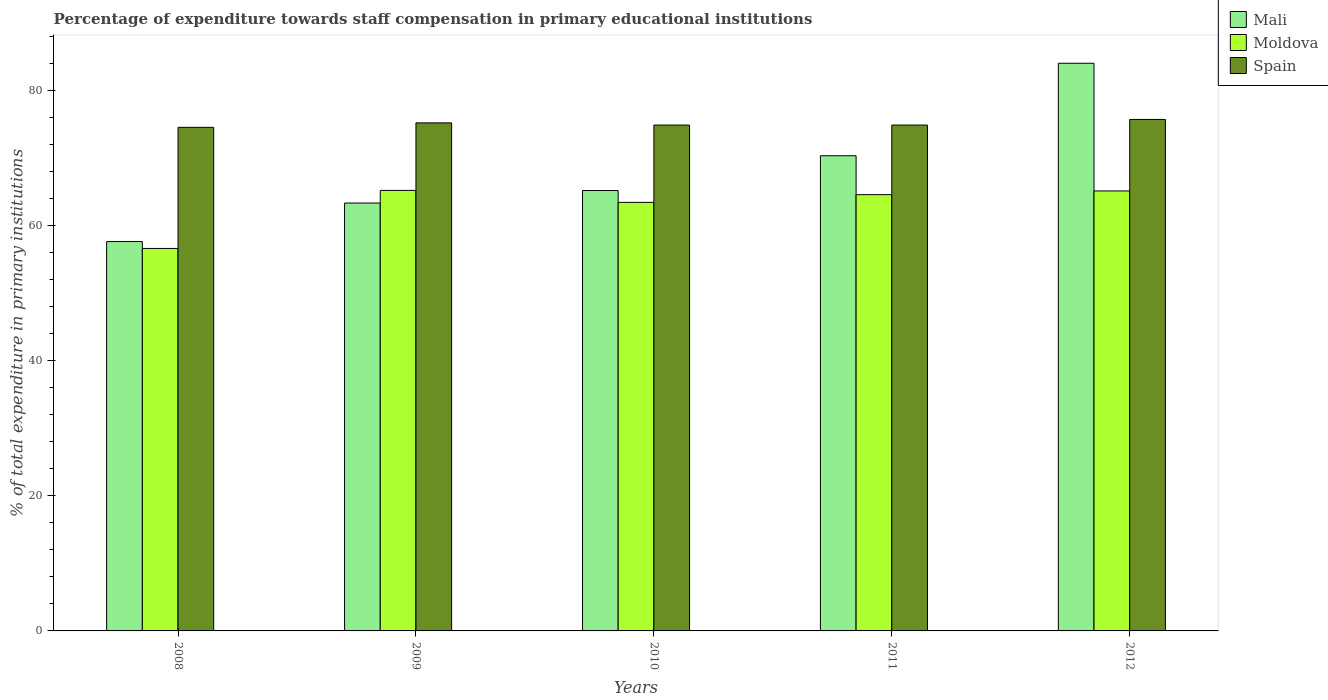How many different coloured bars are there?
Keep it short and to the point. 3. Are the number of bars per tick equal to the number of legend labels?
Provide a short and direct response. Yes. How many bars are there on the 2nd tick from the left?
Offer a very short reply. 3. In how many cases, is the number of bars for a given year not equal to the number of legend labels?
Your answer should be compact. 0. What is the percentage of expenditure towards staff compensation in Mali in 2011?
Your answer should be compact. 70.35. Across all years, what is the maximum percentage of expenditure towards staff compensation in Spain?
Offer a very short reply. 75.72. Across all years, what is the minimum percentage of expenditure towards staff compensation in Spain?
Offer a very short reply. 74.55. In which year was the percentage of expenditure towards staff compensation in Moldova maximum?
Keep it short and to the point. 2009. In which year was the percentage of expenditure towards staff compensation in Spain minimum?
Ensure brevity in your answer.  2008. What is the total percentage of expenditure towards staff compensation in Spain in the graph?
Give a very brief answer. 375.28. What is the difference between the percentage of expenditure towards staff compensation in Spain in 2009 and that in 2011?
Keep it short and to the point. 0.32. What is the difference between the percentage of expenditure towards staff compensation in Spain in 2008 and the percentage of expenditure towards staff compensation in Mali in 2012?
Your answer should be compact. -9.49. What is the average percentage of expenditure towards staff compensation in Mali per year?
Your response must be concise. 68.12. In the year 2009, what is the difference between the percentage of expenditure towards staff compensation in Spain and percentage of expenditure towards staff compensation in Moldova?
Offer a terse response. 10. What is the ratio of the percentage of expenditure towards staff compensation in Spain in 2009 to that in 2011?
Provide a short and direct response. 1. What is the difference between the highest and the second highest percentage of expenditure towards staff compensation in Moldova?
Ensure brevity in your answer.  0.08. What is the difference between the highest and the lowest percentage of expenditure towards staff compensation in Mali?
Keep it short and to the point. 26.39. In how many years, is the percentage of expenditure towards staff compensation in Spain greater than the average percentage of expenditure towards staff compensation in Spain taken over all years?
Keep it short and to the point. 2. What does the 3rd bar from the right in 2008 represents?
Make the answer very short. Mali. How many bars are there?
Provide a short and direct response. 15. Does the graph contain any zero values?
Ensure brevity in your answer.  No. Where does the legend appear in the graph?
Give a very brief answer. Top right. How are the legend labels stacked?
Your answer should be very brief. Vertical. What is the title of the graph?
Offer a very short reply. Percentage of expenditure towards staff compensation in primary educational institutions. Does "Cote d'Ivoire" appear as one of the legend labels in the graph?
Ensure brevity in your answer.  No. What is the label or title of the X-axis?
Make the answer very short. Years. What is the label or title of the Y-axis?
Your answer should be very brief. % of total expenditure in primary institutions. What is the % of total expenditure in primary institutions of Mali in 2008?
Offer a terse response. 57.65. What is the % of total expenditure in primary institutions of Moldova in 2008?
Your answer should be very brief. 56.62. What is the % of total expenditure in primary institutions of Spain in 2008?
Provide a short and direct response. 74.55. What is the % of total expenditure in primary institutions of Mali in 2009?
Make the answer very short. 63.35. What is the % of total expenditure in primary institutions of Moldova in 2009?
Provide a short and direct response. 65.22. What is the % of total expenditure in primary institutions of Spain in 2009?
Give a very brief answer. 75.22. What is the % of total expenditure in primary institutions of Mali in 2010?
Offer a terse response. 65.2. What is the % of total expenditure in primary institutions in Moldova in 2010?
Provide a short and direct response. 63.45. What is the % of total expenditure in primary institutions of Spain in 2010?
Make the answer very short. 74.89. What is the % of total expenditure in primary institutions in Mali in 2011?
Your answer should be very brief. 70.35. What is the % of total expenditure in primary institutions in Moldova in 2011?
Your answer should be compact. 64.59. What is the % of total expenditure in primary institutions in Spain in 2011?
Offer a very short reply. 74.89. What is the % of total expenditure in primary institutions in Mali in 2012?
Provide a succinct answer. 84.04. What is the % of total expenditure in primary institutions in Moldova in 2012?
Your answer should be very brief. 65.14. What is the % of total expenditure in primary institutions of Spain in 2012?
Offer a very short reply. 75.72. Across all years, what is the maximum % of total expenditure in primary institutions of Mali?
Offer a terse response. 84.04. Across all years, what is the maximum % of total expenditure in primary institutions of Moldova?
Make the answer very short. 65.22. Across all years, what is the maximum % of total expenditure in primary institutions in Spain?
Your response must be concise. 75.72. Across all years, what is the minimum % of total expenditure in primary institutions of Mali?
Make the answer very short. 57.65. Across all years, what is the minimum % of total expenditure in primary institutions of Moldova?
Your response must be concise. 56.62. Across all years, what is the minimum % of total expenditure in primary institutions of Spain?
Offer a terse response. 74.55. What is the total % of total expenditure in primary institutions of Mali in the graph?
Keep it short and to the point. 340.58. What is the total % of total expenditure in primary institutions of Moldova in the graph?
Offer a terse response. 315.02. What is the total % of total expenditure in primary institutions of Spain in the graph?
Keep it short and to the point. 375.28. What is the difference between the % of total expenditure in primary institutions in Mali in 2008 and that in 2009?
Ensure brevity in your answer.  -5.7. What is the difference between the % of total expenditure in primary institutions of Moldova in 2008 and that in 2009?
Make the answer very short. -8.59. What is the difference between the % of total expenditure in primary institutions in Spain in 2008 and that in 2009?
Provide a succinct answer. -0.66. What is the difference between the % of total expenditure in primary institutions in Mali in 2008 and that in 2010?
Offer a very short reply. -7.55. What is the difference between the % of total expenditure in primary institutions of Moldova in 2008 and that in 2010?
Give a very brief answer. -6.82. What is the difference between the % of total expenditure in primary institutions in Spain in 2008 and that in 2010?
Provide a succinct answer. -0.34. What is the difference between the % of total expenditure in primary institutions in Mali in 2008 and that in 2011?
Offer a terse response. -12.7. What is the difference between the % of total expenditure in primary institutions of Moldova in 2008 and that in 2011?
Make the answer very short. -7.96. What is the difference between the % of total expenditure in primary institutions of Spain in 2008 and that in 2011?
Your answer should be compact. -0.34. What is the difference between the % of total expenditure in primary institutions of Mali in 2008 and that in 2012?
Your response must be concise. -26.39. What is the difference between the % of total expenditure in primary institutions of Moldova in 2008 and that in 2012?
Keep it short and to the point. -8.51. What is the difference between the % of total expenditure in primary institutions of Spain in 2008 and that in 2012?
Offer a very short reply. -1.17. What is the difference between the % of total expenditure in primary institutions of Mali in 2009 and that in 2010?
Provide a succinct answer. -1.85. What is the difference between the % of total expenditure in primary institutions in Moldova in 2009 and that in 2010?
Make the answer very short. 1.77. What is the difference between the % of total expenditure in primary institutions of Spain in 2009 and that in 2010?
Your answer should be very brief. 0.32. What is the difference between the % of total expenditure in primary institutions of Mali in 2009 and that in 2011?
Give a very brief answer. -7. What is the difference between the % of total expenditure in primary institutions of Moldova in 2009 and that in 2011?
Keep it short and to the point. 0.63. What is the difference between the % of total expenditure in primary institutions of Spain in 2009 and that in 2011?
Ensure brevity in your answer.  0.32. What is the difference between the % of total expenditure in primary institutions of Mali in 2009 and that in 2012?
Provide a succinct answer. -20.69. What is the difference between the % of total expenditure in primary institutions in Moldova in 2009 and that in 2012?
Provide a short and direct response. 0.08. What is the difference between the % of total expenditure in primary institutions of Spain in 2009 and that in 2012?
Ensure brevity in your answer.  -0.51. What is the difference between the % of total expenditure in primary institutions of Mali in 2010 and that in 2011?
Keep it short and to the point. -5.15. What is the difference between the % of total expenditure in primary institutions of Moldova in 2010 and that in 2011?
Provide a short and direct response. -1.14. What is the difference between the % of total expenditure in primary institutions of Mali in 2010 and that in 2012?
Ensure brevity in your answer.  -18.84. What is the difference between the % of total expenditure in primary institutions in Moldova in 2010 and that in 2012?
Your response must be concise. -1.69. What is the difference between the % of total expenditure in primary institutions of Spain in 2010 and that in 2012?
Ensure brevity in your answer.  -0.83. What is the difference between the % of total expenditure in primary institutions of Mali in 2011 and that in 2012?
Your response must be concise. -13.69. What is the difference between the % of total expenditure in primary institutions of Moldova in 2011 and that in 2012?
Provide a short and direct response. -0.55. What is the difference between the % of total expenditure in primary institutions of Spain in 2011 and that in 2012?
Ensure brevity in your answer.  -0.83. What is the difference between the % of total expenditure in primary institutions in Mali in 2008 and the % of total expenditure in primary institutions in Moldova in 2009?
Keep it short and to the point. -7.57. What is the difference between the % of total expenditure in primary institutions in Mali in 2008 and the % of total expenditure in primary institutions in Spain in 2009?
Offer a very short reply. -17.57. What is the difference between the % of total expenditure in primary institutions of Moldova in 2008 and the % of total expenditure in primary institutions of Spain in 2009?
Your response must be concise. -18.59. What is the difference between the % of total expenditure in primary institutions of Mali in 2008 and the % of total expenditure in primary institutions of Moldova in 2010?
Give a very brief answer. -5.8. What is the difference between the % of total expenditure in primary institutions of Mali in 2008 and the % of total expenditure in primary institutions of Spain in 2010?
Ensure brevity in your answer.  -17.25. What is the difference between the % of total expenditure in primary institutions of Moldova in 2008 and the % of total expenditure in primary institutions of Spain in 2010?
Make the answer very short. -18.27. What is the difference between the % of total expenditure in primary institutions of Mali in 2008 and the % of total expenditure in primary institutions of Moldova in 2011?
Provide a short and direct response. -6.94. What is the difference between the % of total expenditure in primary institutions in Mali in 2008 and the % of total expenditure in primary institutions in Spain in 2011?
Provide a short and direct response. -17.25. What is the difference between the % of total expenditure in primary institutions in Moldova in 2008 and the % of total expenditure in primary institutions in Spain in 2011?
Keep it short and to the point. -18.27. What is the difference between the % of total expenditure in primary institutions in Mali in 2008 and the % of total expenditure in primary institutions in Moldova in 2012?
Your answer should be compact. -7.49. What is the difference between the % of total expenditure in primary institutions of Mali in 2008 and the % of total expenditure in primary institutions of Spain in 2012?
Give a very brief answer. -18.08. What is the difference between the % of total expenditure in primary institutions in Moldova in 2008 and the % of total expenditure in primary institutions in Spain in 2012?
Your answer should be very brief. -19.1. What is the difference between the % of total expenditure in primary institutions of Mali in 2009 and the % of total expenditure in primary institutions of Moldova in 2010?
Your response must be concise. -0.1. What is the difference between the % of total expenditure in primary institutions of Mali in 2009 and the % of total expenditure in primary institutions of Spain in 2010?
Keep it short and to the point. -11.55. What is the difference between the % of total expenditure in primary institutions of Moldova in 2009 and the % of total expenditure in primary institutions of Spain in 2010?
Offer a terse response. -9.68. What is the difference between the % of total expenditure in primary institutions in Mali in 2009 and the % of total expenditure in primary institutions in Moldova in 2011?
Provide a succinct answer. -1.24. What is the difference between the % of total expenditure in primary institutions of Mali in 2009 and the % of total expenditure in primary institutions of Spain in 2011?
Your answer should be very brief. -11.55. What is the difference between the % of total expenditure in primary institutions of Moldova in 2009 and the % of total expenditure in primary institutions of Spain in 2011?
Your answer should be compact. -9.68. What is the difference between the % of total expenditure in primary institutions in Mali in 2009 and the % of total expenditure in primary institutions in Moldova in 2012?
Provide a succinct answer. -1.79. What is the difference between the % of total expenditure in primary institutions in Mali in 2009 and the % of total expenditure in primary institutions in Spain in 2012?
Your response must be concise. -12.38. What is the difference between the % of total expenditure in primary institutions of Moldova in 2009 and the % of total expenditure in primary institutions of Spain in 2012?
Provide a succinct answer. -10.51. What is the difference between the % of total expenditure in primary institutions of Mali in 2010 and the % of total expenditure in primary institutions of Moldova in 2011?
Your response must be concise. 0.61. What is the difference between the % of total expenditure in primary institutions in Mali in 2010 and the % of total expenditure in primary institutions in Spain in 2011?
Ensure brevity in your answer.  -9.69. What is the difference between the % of total expenditure in primary institutions in Moldova in 2010 and the % of total expenditure in primary institutions in Spain in 2011?
Offer a terse response. -11.45. What is the difference between the % of total expenditure in primary institutions of Mali in 2010 and the % of total expenditure in primary institutions of Moldova in 2012?
Your response must be concise. 0.06. What is the difference between the % of total expenditure in primary institutions in Mali in 2010 and the % of total expenditure in primary institutions in Spain in 2012?
Provide a succinct answer. -10.52. What is the difference between the % of total expenditure in primary institutions in Moldova in 2010 and the % of total expenditure in primary institutions in Spain in 2012?
Your response must be concise. -12.28. What is the difference between the % of total expenditure in primary institutions in Mali in 2011 and the % of total expenditure in primary institutions in Moldova in 2012?
Keep it short and to the point. 5.21. What is the difference between the % of total expenditure in primary institutions in Mali in 2011 and the % of total expenditure in primary institutions in Spain in 2012?
Keep it short and to the point. -5.38. What is the difference between the % of total expenditure in primary institutions of Moldova in 2011 and the % of total expenditure in primary institutions of Spain in 2012?
Ensure brevity in your answer.  -11.14. What is the average % of total expenditure in primary institutions in Mali per year?
Provide a succinct answer. 68.12. What is the average % of total expenditure in primary institutions of Moldova per year?
Ensure brevity in your answer.  63. What is the average % of total expenditure in primary institutions of Spain per year?
Your answer should be very brief. 75.06. In the year 2008, what is the difference between the % of total expenditure in primary institutions in Mali and % of total expenditure in primary institutions in Moldova?
Your response must be concise. 1.02. In the year 2008, what is the difference between the % of total expenditure in primary institutions of Mali and % of total expenditure in primary institutions of Spain?
Provide a succinct answer. -16.9. In the year 2008, what is the difference between the % of total expenditure in primary institutions of Moldova and % of total expenditure in primary institutions of Spain?
Provide a succinct answer. -17.93. In the year 2009, what is the difference between the % of total expenditure in primary institutions of Mali and % of total expenditure in primary institutions of Moldova?
Give a very brief answer. -1.87. In the year 2009, what is the difference between the % of total expenditure in primary institutions in Mali and % of total expenditure in primary institutions in Spain?
Provide a short and direct response. -11.87. In the year 2009, what is the difference between the % of total expenditure in primary institutions of Moldova and % of total expenditure in primary institutions of Spain?
Provide a short and direct response. -10. In the year 2010, what is the difference between the % of total expenditure in primary institutions in Mali and % of total expenditure in primary institutions in Moldova?
Give a very brief answer. 1.75. In the year 2010, what is the difference between the % of total expenditure in primary institutions of Mali and % of total expenditure in primary institutions of Spain?
Make the answer very short. -9.69. In the year 2010, what is the difference between the % of total expenditure in primary institutions in Moldova and % of total expenditure in primary institutions in Spain?
Your answer should be compact. -11.45. In the year 2011, what is the difference between the % of total expenditure in primary institutions of Mali and % of total expenditure in primary institutions of Moldova?
Your response must be concise. 5.76. In the year 2011, what is the difference between the % of total expenditure in primary institutions of Mali and % of total expenditure in primary institutions of Spain?
Give a very brief answer. -4.55. In the year 2011, what is the difference between the % of total expenditure in primary institutions in Moldova and % of total expenditure in primary institutions in Spain?
Give a very brief answer. -10.3. In the year 2012, what is the difference between the % of total expenditure in primary institutions of Mali and % of total expenditure in primary institutions of Moldova?
Make the answer very short. 18.9. In the year 2012, what is the difference between the % of total expenditure in primary institutions of Mali and % of total expenditure in primary institutions of Spain?
Your response must be concise. 8.32. In the year 2012, what is the difference between the % of total expenditure in primary institutions of Moldova and % of total expenditure in primary institutions of Spain?
Provide a succinct answer. -10.59. What is the ratio of the % of total expenditure in primary institutions of Mali in 2008 to that in 2009?
Ensure brevity in your answer.  0.91. What is the ratio of the % of total expenditure in primary institutions in Moldova in 2008 to that in 2009?
Provide a succinct answer. 0.87. What is the ratio of the % of total expenditure in primary institutions of Mali in 2008 to that in 2010?
Offer a terse response. 0.88. What is the ratio of the % of total expenditure in primary institutions of Moldova in 2008 to that in 2010?
Provide a short and direct response. 0.89. What is the ratio of the % of total expenditure in primary institutions in Mali in 2008 to that in 2011?
Make the answer very short. 0.82. What is the ratio of the % of total expenditure in primary institutions in Moldova in 2008 to that in 2011?
Your answer should be very brief. 0.88. What is the ratio of the % of total expenditure in primary institutions of Spain in 2008 to that in 2011?
Provide a short and direct response. 1. What is the ratio of the % of total expenditure in primary institutions in Mali in 2008 to that in 2012?
Your response must be concise. 0.69. What is the ratio of the % of total expenditure in primary institutions of Moldova in 2008 to that in 2012?
Your answer should be compact. 0.87. What is the ratio of the % of total expenditure in primary institutions of Spain in 2008 to that in 2012?
Give a very brief answer. 0.98. What is the ratio of the % of total expenditure in primary institutions of Mali in 2009 to that in 2010?
Your answer should be compact. 0.97. What is the ratio of the % of total expenditure in primary institutions of Moldova in 2009 to that in 2010?
Offer a terse response. 1.03. What is the ratio of the % of total expenditure in primary institutions in Mali in 2009 to that in 2011?
Offer a terse response. 0.9. What is the ratio of the % of total expenditure in primary institutions in Moldova in 2009 to that in 2011?
Keep it short and to the point. 1.01. What is the ratio of the % of total expenditure in primary institutions of Mali in 2009 to that in 2012?
Your response must be concise. 0.75. What is the ratio of the % of total expenditure in primary institutions in Mali in 2010 to that in 2011?
Provide a succinct answer. 0.93. What is the ratio of the % of total expenditure in primary institutions of Moldova in 2010 to that in 2011?
Your answer should be very brief. 0.98. What is the ratio of the % of total expenditure in primary institutions of Spain in 2010 to that in 2011?
Keep it short and to the point. 1. What is the ratio of the % of total expenditure in primary institutions in Mali in 2010 to that in 2012?
Provide a short and direct response. 0.78. What is the ratio of the % of total expenditure in primary institutions of Mali in 2011 to that in 2012?
Your answer should be very brief. 0.84. What is the ratio of the % of total expenditure in primary institutions in Moldova in 2011 to that in 2012?
Your answer should be compact. 0.99. What is the difference between the highest and the second highest % of total expenditure in primary institutions in Mali?
Give a very brief answer. 13.69. What is the difference between the highest and the second highest % of total expenditure in primary institutions of Moldova?
Your response must be concise. 0.08. What is the difference between the highest and the second highest % of total expenditure in primary institutions of Spain?
Offer a terse response. 0.51. What is the difference between the highest and the lowest % of total expenditure in primary institutions in Mali?
Keep it short and to the point. 26.39. What is the difference between the highest and the lowest % of total expenditure in primary institutions in Moldova?
Offer a terse response. 8.59. What is the difference between the highest and the lowest % of total expenditure in primary institutions in Spain?
Make the answer very short. 1.17. 